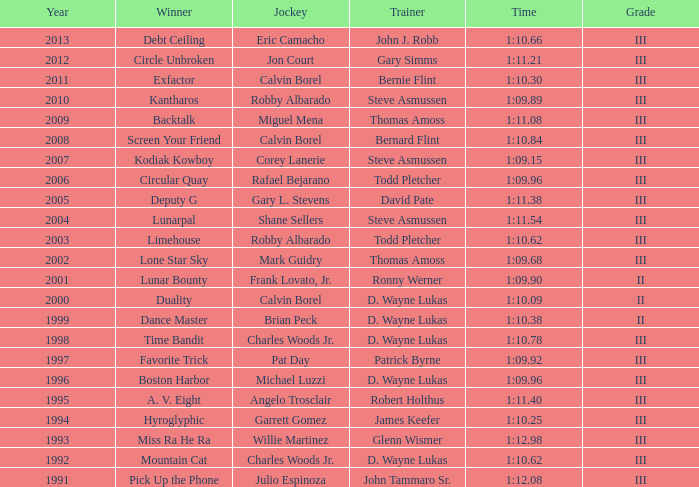What was the duration for screen your friend? 1:10.84. 